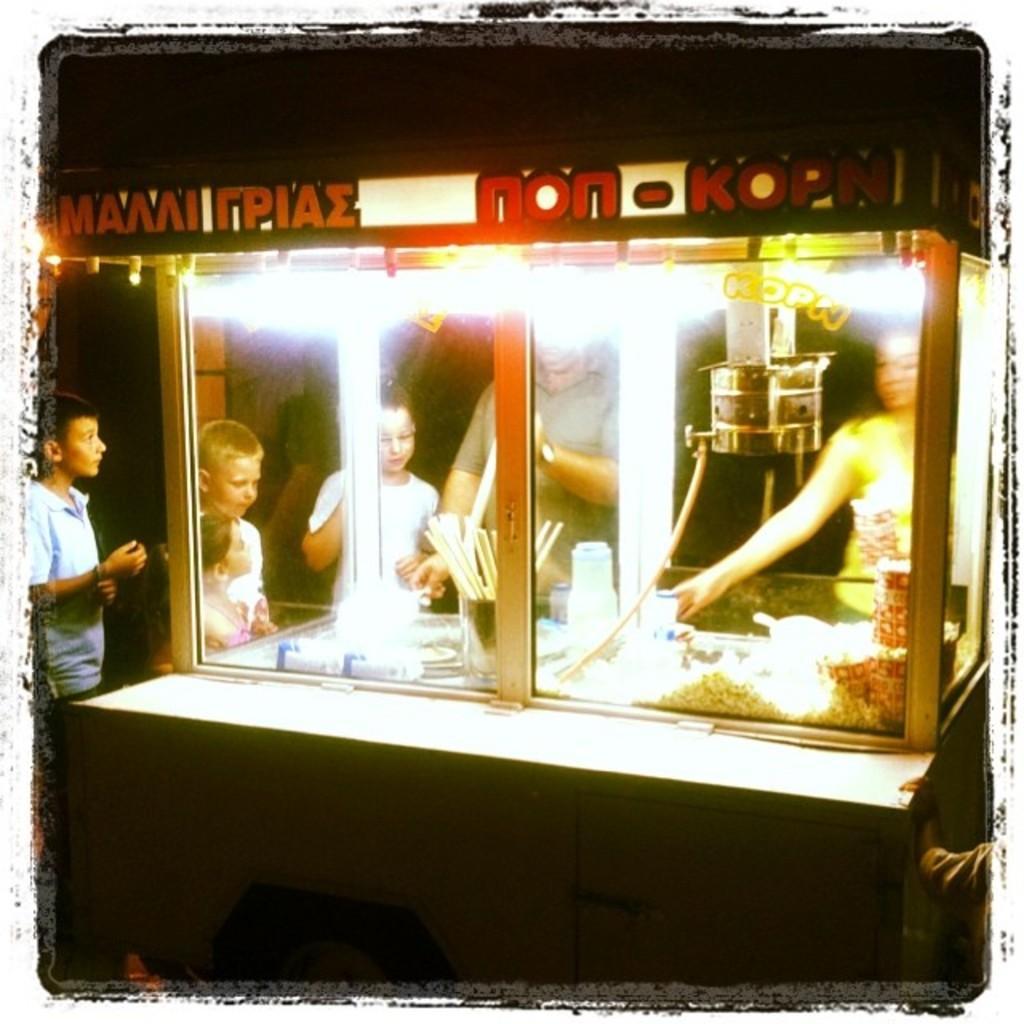In one or two sentences, can you explain what this image depicts? Here we can see a stall and there are few persons. Here we can see bottles, sticks, glasses, and food. 